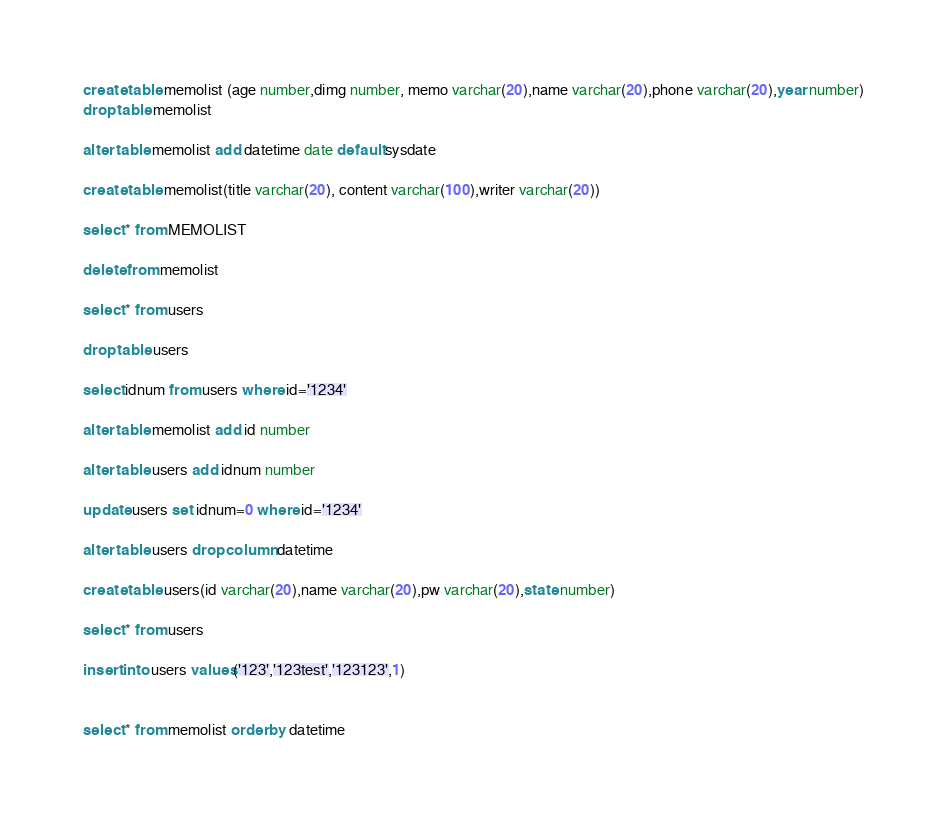<code> <loc_0><loc_0><loc_500><loc_500><_SQL_>create table memolist (age number,dimg number, memo varchar(20),name varchar(20),phone varchar(20),year number)
drop table memolist

alter table memolist add datetime date default sysdate

create table memolist(title varchar(20), content varchar(100),writer varchar(20))

select * from MEMOLIST

delete from memolist

select * from users

drop table users

select idnum from users where id='1234'

alter table memolist add id number

alter table users add idnum number

update users set idnum=0 where id='1234' 

alter table users drop column datetime

create table users(id varchar(20),name varchar(20),pw varchar(20),state number)

select * from users

insert into users values('123','123test','123123',1)


select * from memolist order by datetime


</code> 